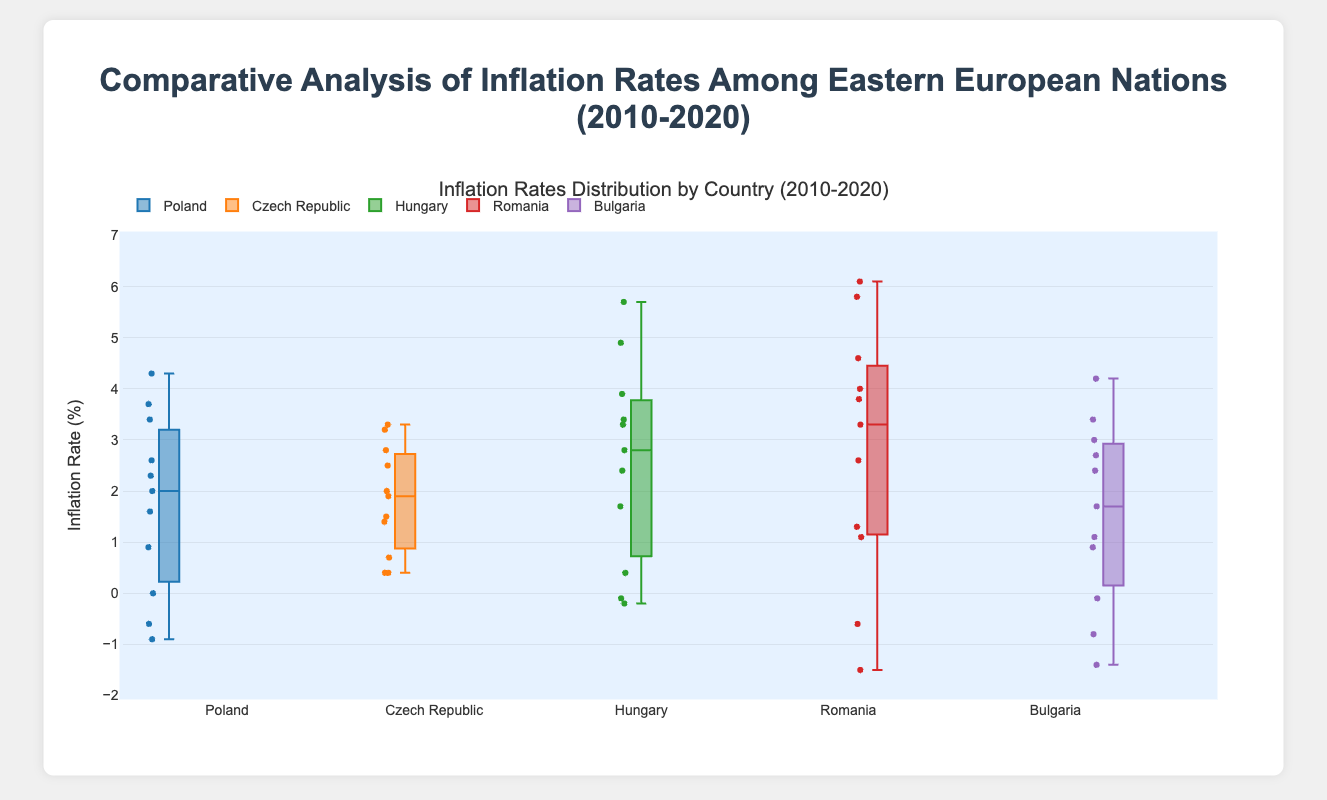What is the range of the inflation rates for Poland? The range is calculated as the difference between the maximum and minimum values. From the box plot, the maximum inflation rate for Poland is around 4.3%, and the minimum is around -0.9%. So, 4.3 - (-0.9) = 5.2.
Answer: 5.2% Which country had the highest median inflation rate? The median inflation rate is represented by the line within each box. From the box plot, the median line of Romania is higher than the other countries' median lines, showing it has the highest median inflation rate.
Answer: Romania How does the interquartile range (IQR) of inflation rates compare between Poland and Hungary? The IQR is the range between the first quartile (Q1) and the third quartile (Q3). For Poland, Q1 is around 0.0%, and Q3 is around 3.0%, making the IQR 3.0 - 0.0 = 3.0. For Hungary, Q1 is roughly 0.0%, and Q3 is around 3.4%, making the IQR 3.4 - 0.0 = 3.4. Thus, Hungary's IQR is larger than Poland's.
Answer: Hungary's IQR is larger Which country exhibits the most variability in its inflation rates? Variability can be assessed using the length of the box and any whiskers or outliers in the box plot. Romania shows the most variability, indicated by a wider spread between the quartiles and extended whiskers or outliers.
Answer: Romania What is the difference between the median inflation rates of Poland and the Czech Republic? The median rate is the line within each box. In the box plot, Poland's median is around 2.0%, and the Czech Republic's median is around 2.0%. Thus, the difference is 0.0%
Answer: 0.0% How many countries have a negative minimum inflation rate? The countries with negative minimum values have box plots extending below 0%. From the box plot, Poland, Hungary, and Bulgaria have minimum values below 0%, thus there are 3 countries with negative minimum inflation rates.
Answer: 3 Which country had the maximum recorded inflation rate and what was it? From the box plot, the highest point among all the data points represents the maximum recorded inflation rate. Romania has a maximum outlier around 6.1%.
Answer: Romania, 6.1% Between 2010 and 2020, which country's inflation rate whiskers do not extend into the negative range? The whiskers extending into the negative range indicate the presence of negative inflation rates. For the Czech Republic, the whiskers do not extend into the negative range, indicating no negative inflation rates in this range.
Answer: Czech Republic What is the median inflation rate for Bulgaria? The median inflation rate can be identified by the line within the box of Bulgaria. The median is around 1.1%.
Answer: 1.1% How does the maximum inflation rate of Poland compare to Hungary's median inflation rate? The maximum inflation rate of Poland is around 4.3%. The median inflation rate of Hungary is around 2.4%. The comparison shows that Poland's maximum inflation rate is higher than Hungary's median inflation rate.
Answer: Poland's maximum is higher 